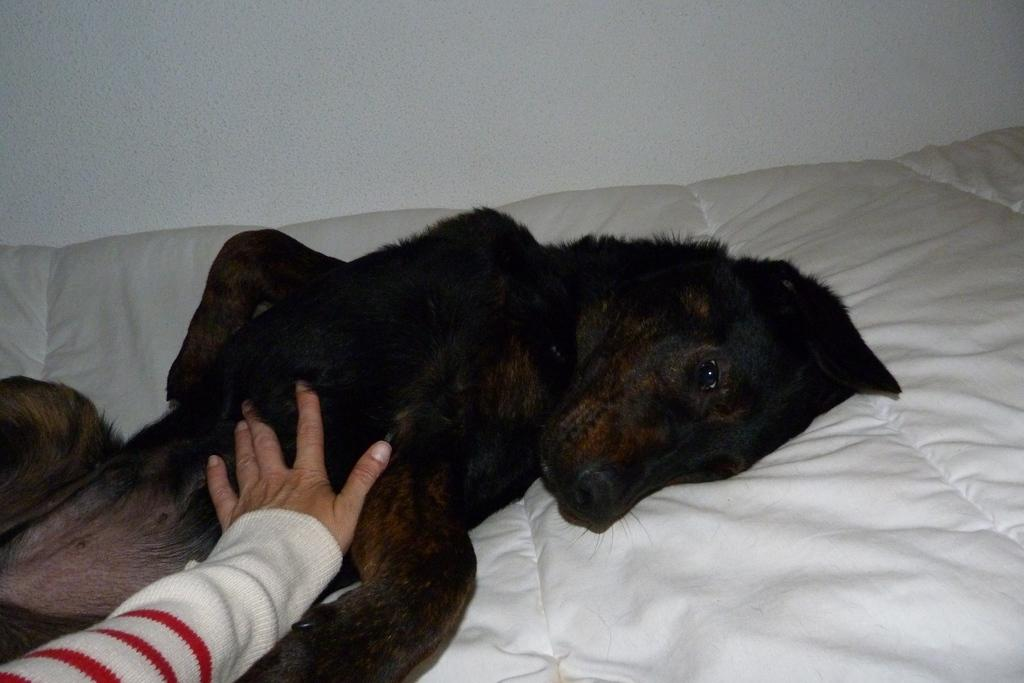What animal is present in the image? There is a dog in the image. Where is the dog located in the image? The dog is lying in the center of the image. Is there any interaction with the dog in the image? Yes, there is a hand on the dog in the image. What type of toys can be seen in the image? There are no toys present in the image; it features a dog lying in the center with a hand on it. Can you hear a horn playing in the background of the image? There is no sound or reference to a horn in the image, as it is a still photograph. 